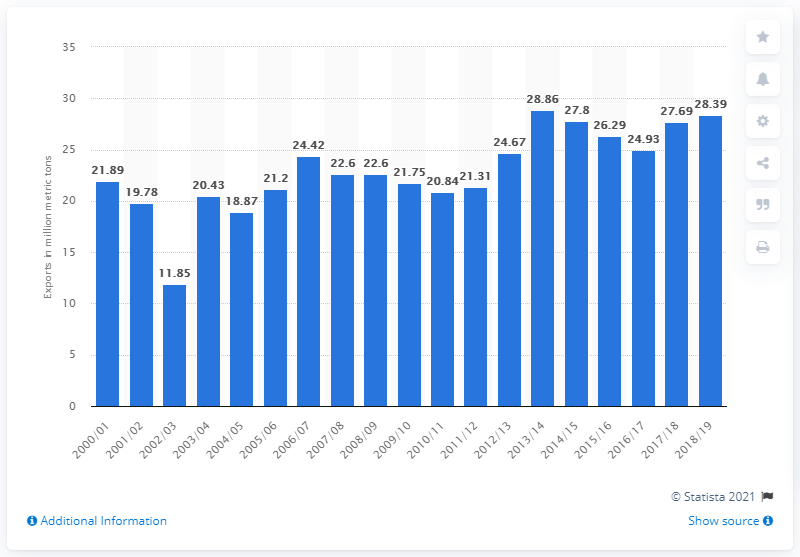Indicate a few pertinent items in this graphic. In the 2018/19 fiscal year, Canada's total cereal exports amounted to 28.39 million metric tons. 